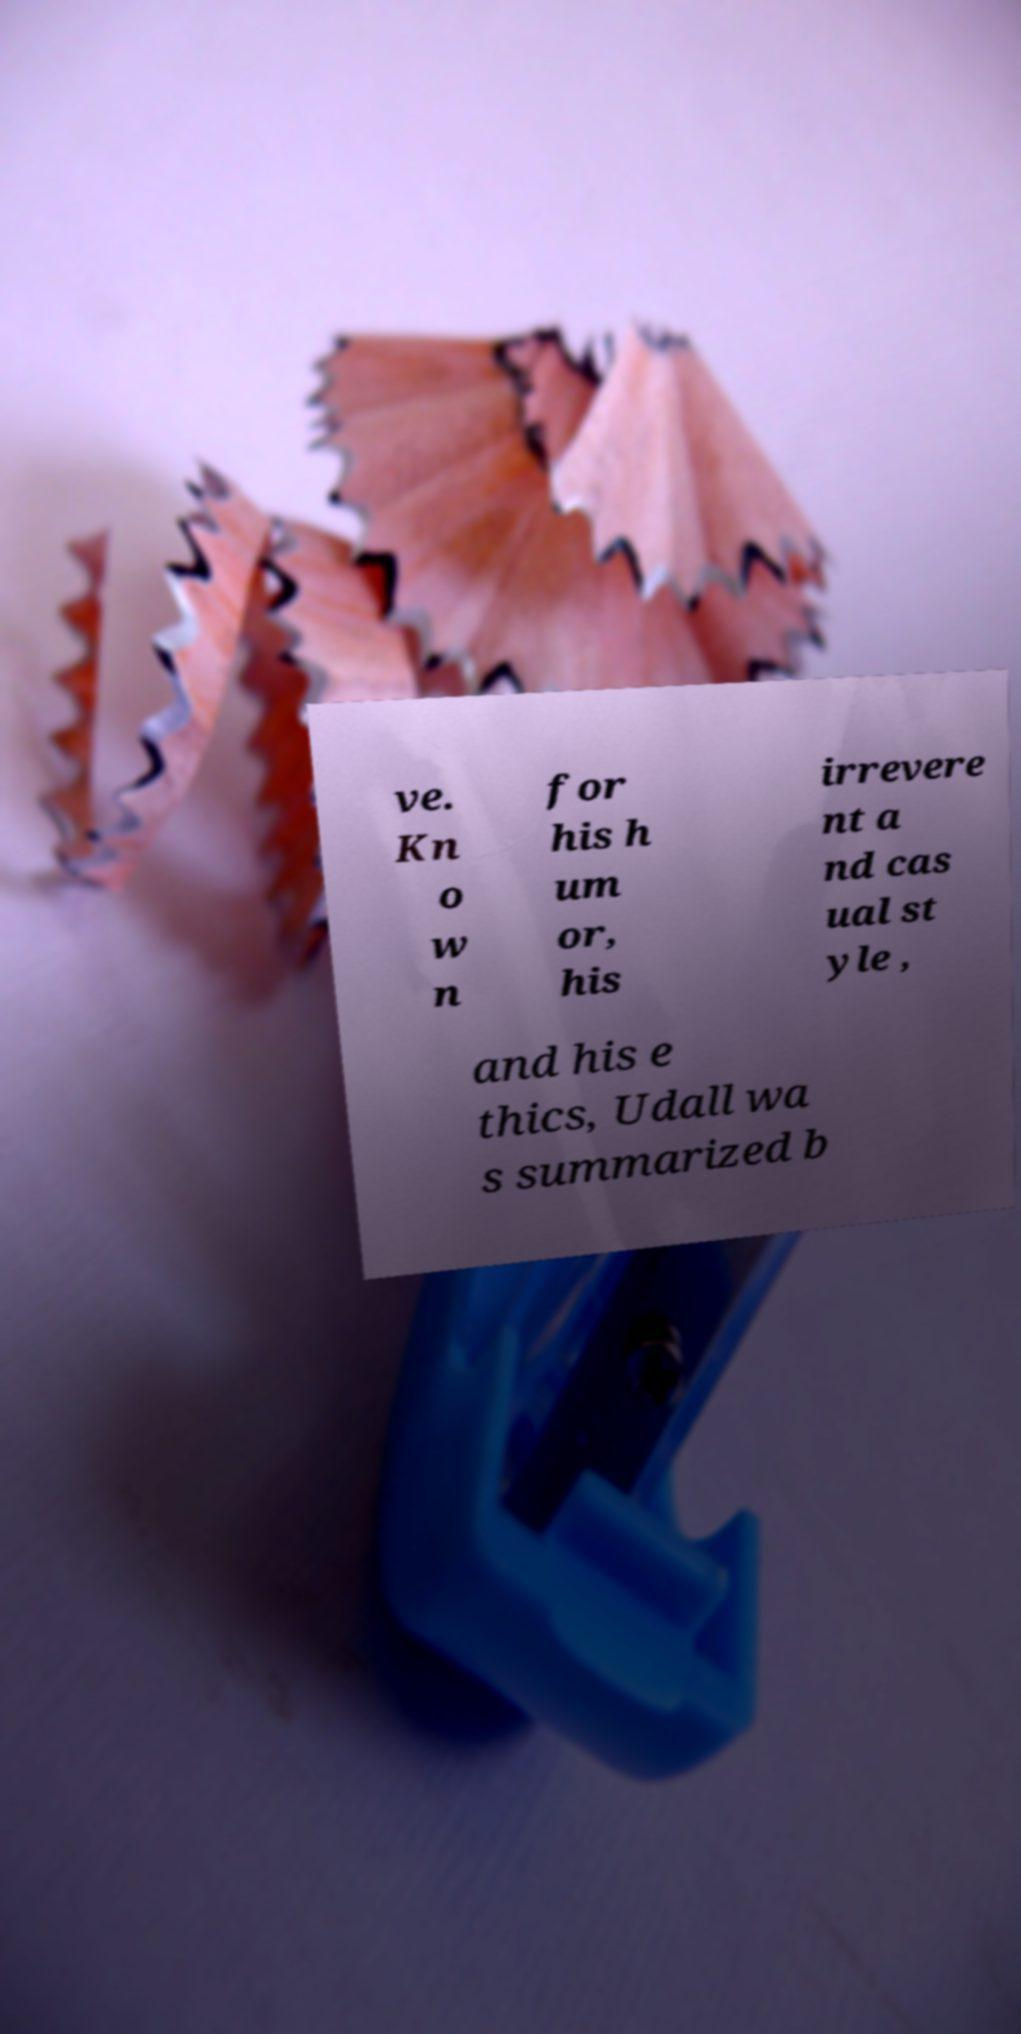What messages or text are displayed in this image? I need them in a readable, typed format. ve. Kn o w n for his h um or, his irrevere nt a nd cas ual st yle , and his e thics, Udall wa s summarized b 